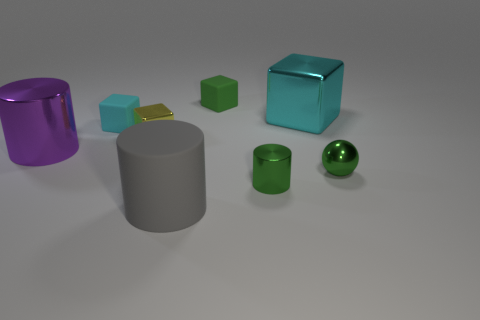What textures do the objects have? The objects exhibit a variety of textures. The green cube and small green cuboid have a matte finish, while the cyan cube, purple cylinder, and green sphere are glossy. The yellow cuboid and gray cylinder have less reflective, satiny surfaces. 